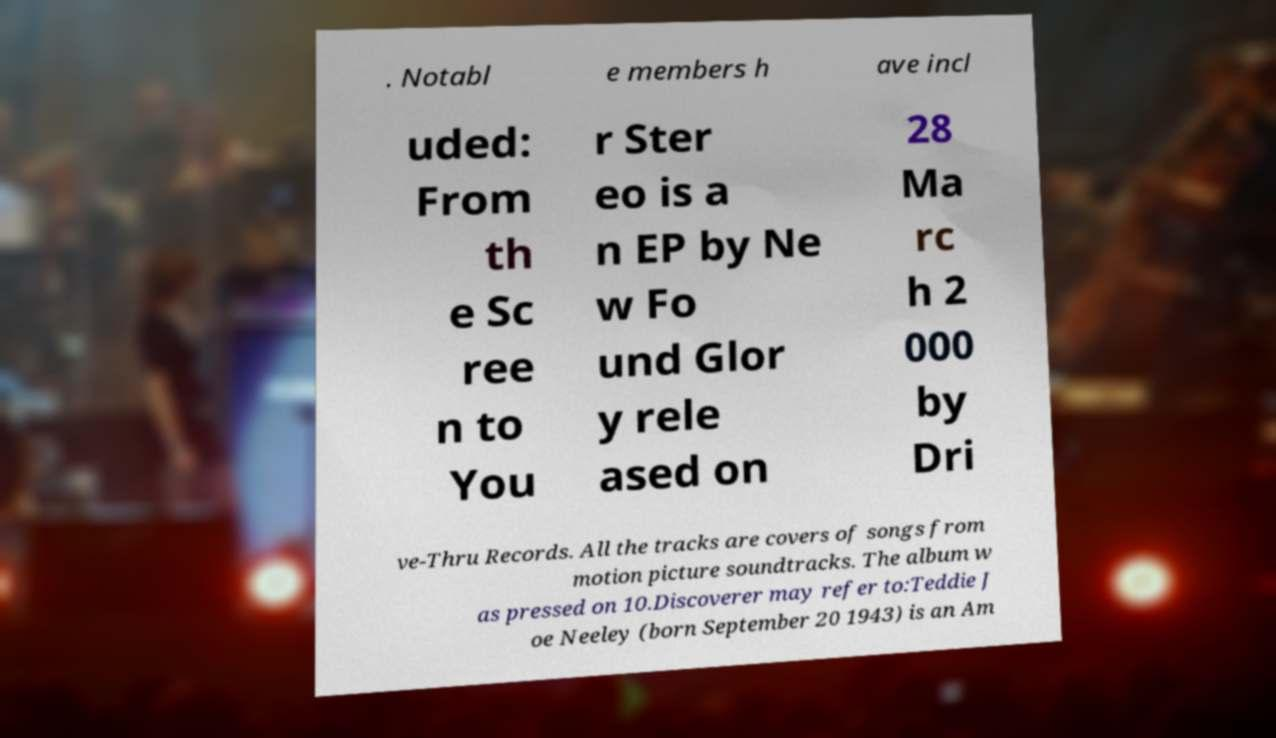Can you accurately transcribe the text from the provided image for me? . Notabl e members h ave incl uded: From th e Sc ree n to You r Ster eo is a n EP by Ne w Fo und Glor y rele ased on 28 Ma rc h 2 000 by Dri ve-Thru Records. All the tracks are covers of songs from motion picture soundtracks. The album w as pressed on 10.Discoverer may refer to:Teddie J oe Neeley (born September 20 1943) is an Am 